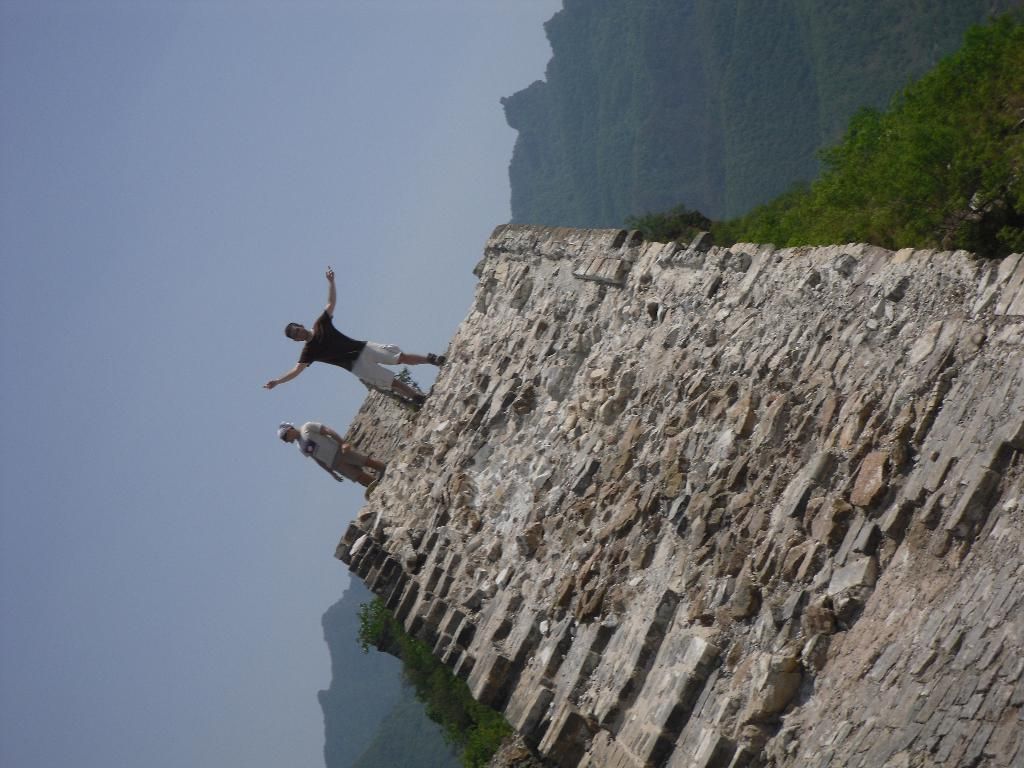How many persons are in the image? There are two persons in the image. What are the persons doing in the image? The persons are standing on a big rock. What type of vegetation can be seen in the image? There are trees, plants, and bushes in the image. What is the ground made of in the image? There is grass in the image. Where is the grass located in the image? The grass is over the mountains. What is visible at the top of the image? The sky is visible at the top of the image. What type of books can be seen in the library in the image? There is no library present in the image; it features two persons standing on a big rock with various types of vegetation, mountains, and the sky visible. 